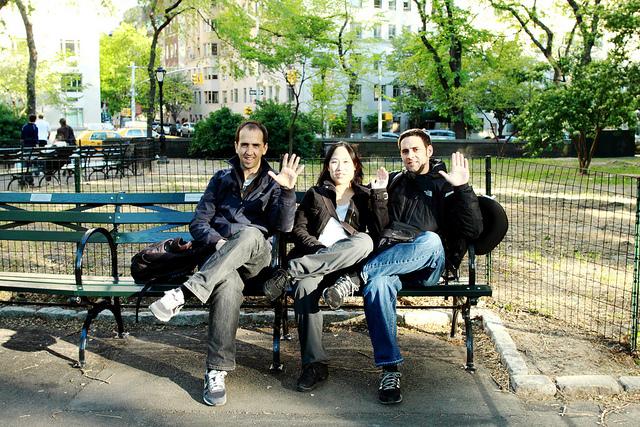How many people only have black shoes?
Write a very short answer. 2. What are the people doing with their hands?
Keep it brief. Waving. What is the ratio of males to females in this picture?
Quick response, please. 2:1. 